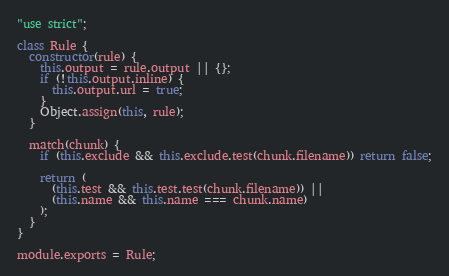<code> <loc_0><loc_0><loc_500><loc_500><_JavaScript_>"use strict";

class Rule {
  constructor(rule) {
    this.output = rule.output || {};
    if (!this.output.inline) {
      this.output.url = true;
    }
    Object.assign(this, rule);
  }

  match(chunk) {
    if (this.exclude && this.exclude.test(chunk.filename)) return false;

    return (
      (this.test && this.test.test(chunk.filename)) ||
      (this.name && this.name === chunk.name)
    );
  }
}

module.exports = Rule;
</code> 